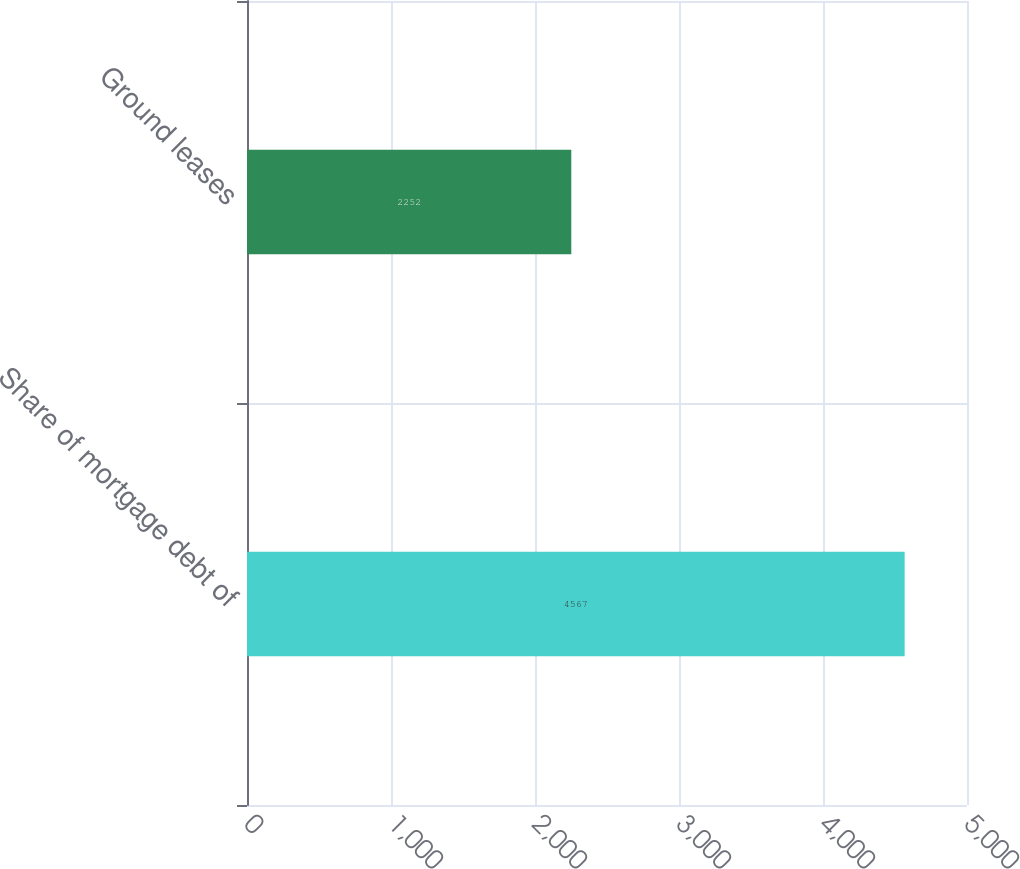Convert chart to OTSL. <chart><loc_0><loc_0><loc_500><loc_500><bar_chart><fcel>Share of mortgage debt of<fcel>Ground leases<nl><fcel>4567<fcel>2252<nl></chart> 